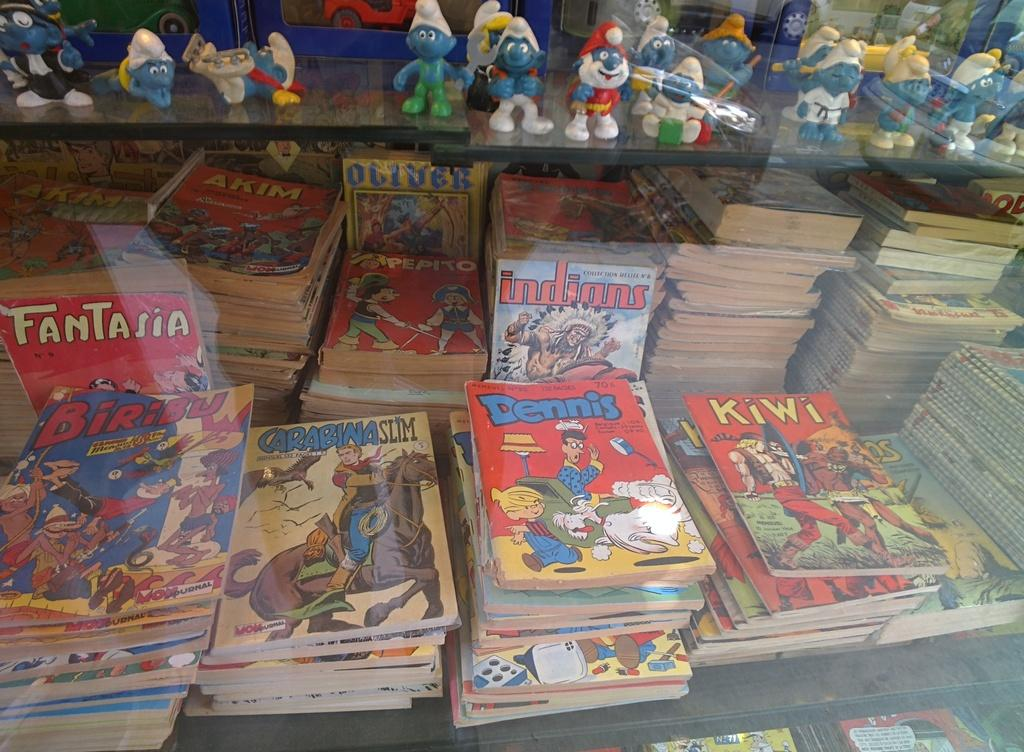<image>
Share a concise interpretation of the image provided. several stacks of comic books like fantasia, Dennis and kiwi. 